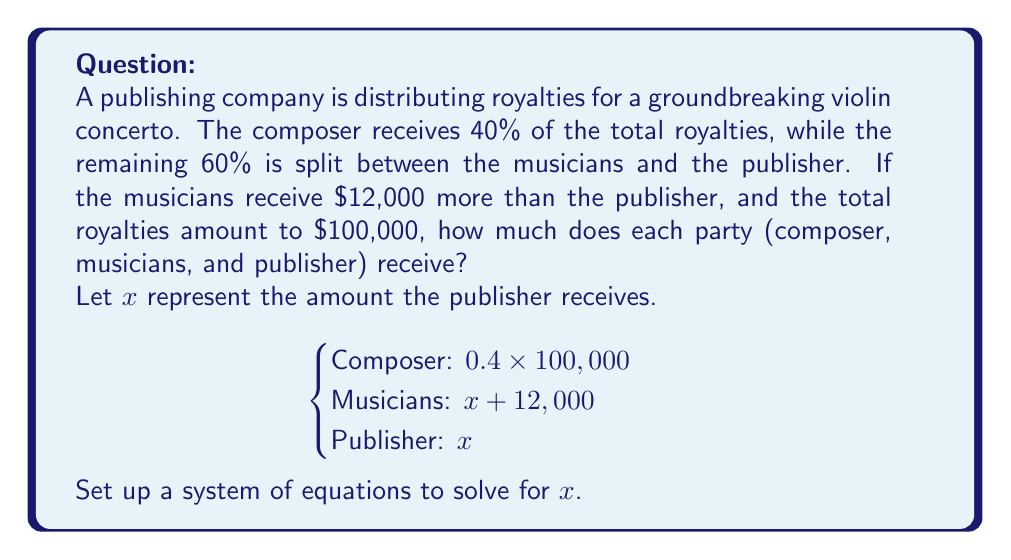Provide a solution to this math problem. Let's solve this problem step by step:

1. First, we know that the total royalties are $100,000, and the composer receives 40% of this:
   Composer's share = $0.4 \times 100,000 = 40,000$

2. The remaining 60% ($60,000) is split between the musicians and the publisher:
   $60,000 = (x + 12,000) + x$, where $x$ is the publisher's share

3. Let's set up an equation:
   $60,000 = x + 12,000 + x$
   $60,000 = 2x + 12,000$

4. Solve for $x$:
   $2x = 60,000 - 12,000$
   $2x = 48,000$
   $x = 24,000$

5. Now that we know the publisher's share ($x = 24,000$), we can calculate the musicians' share:
   Musicians' share = $x + 12,000 = 24,000 + 12,000 = 36,000$

6. Let's verify that the total adds up to $100,000:
   $40,000 + 36,000 + 24,000 = 100,000$

Therefore, the distribution of royalties is:
- Composer: $40,000
- Musicians: $36,000
- Publisher: $24,000
Answer: Composer: $40,000
Musicians: $36,000
Publisher: $24,000 